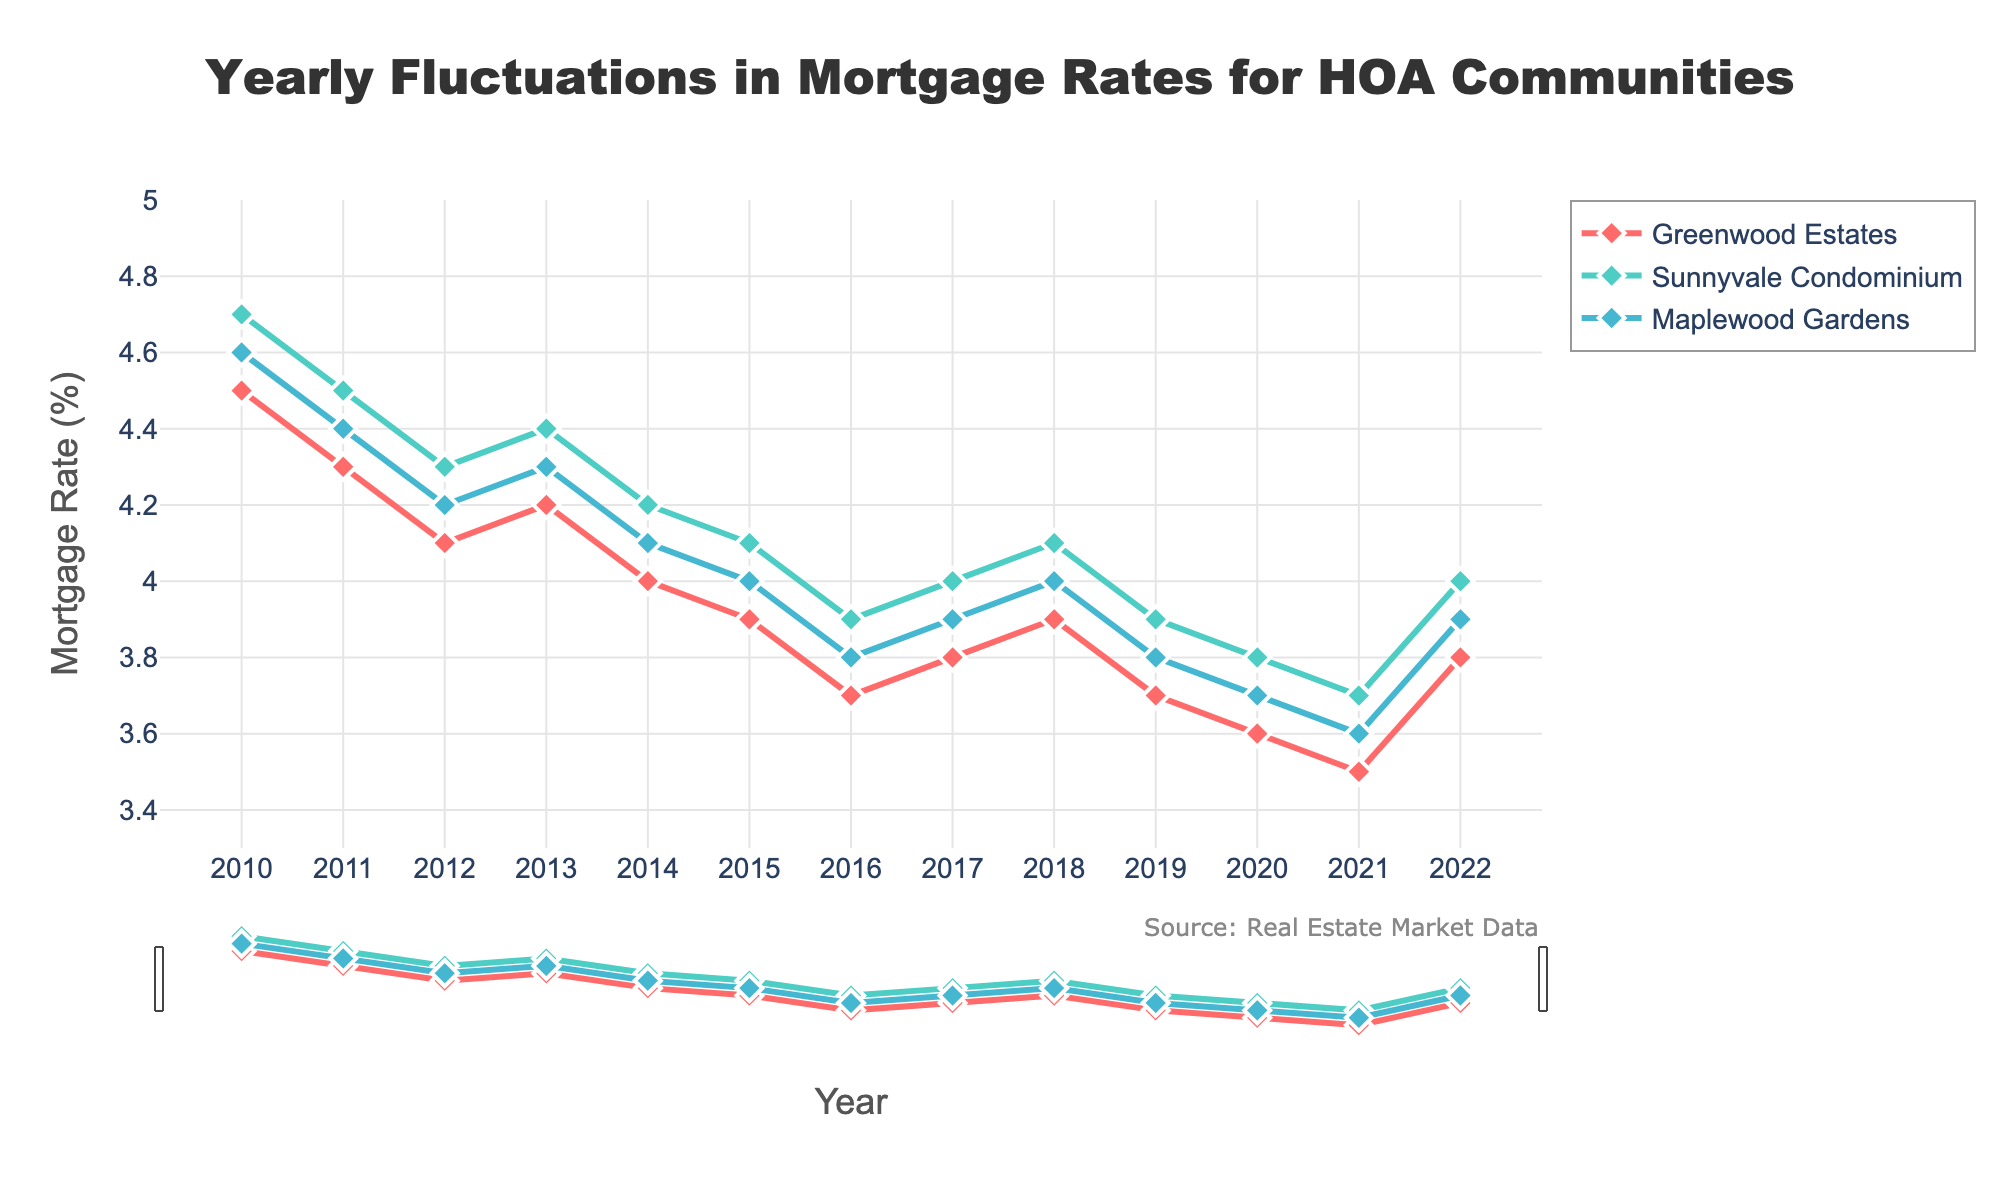What's the title of the plot? The title is displayed prominently at the top of the figure. It is "Yearly Fluctuations in Mortgage Rates for HOA Communities".
Answer: Yearly Fluctuations in Mortgage Rates for HOA Communities Which community has the lowest mortgage rate in 2016? Find the year 2016 on the x-axis, then see which community's line is at the lowest point on the y-axis. Greenwood Estates has the lowest rate of 3.7%.
Answer: Greenwood Estates In which year did all communities have the same mortgage rate? Compare the lines for all three communities year by year. In 2013, all communities had virtually the same mortgage rate of about 4.2-4.4%.
Answer: 2013 What's the trend of mortgage rates for Greenwood Estates from 2010 to 2022? Observe the line for Greenwood Estates from 2010 to 2022. The rate generally decreases until 2021, then slightly increases in 2022.
Answer: Decreasing, then slightly increasing in 2022 Which community exhibited the most stable mortgage rate fluctuations over the years? Look at the slopes of the lines for each community. Sunnyvale Condominium's line shows the least fluctuation.
Answer: Sunnyvale Condominium By how much did the mortgage rate for Maplewood Gardens decrease from 2010 to 2020? Subtract Maplewood Gardens' 2020 rate from its 2010 rate: 4.6 - 3.7 = 0.9%.
Answer: 0.9% Which year had the highest mortgage rate for Sunnyvale Condominium? Find the peak point on the line for Sunnyvale Condominium. The highest rate was in 2010, at 4.7%.
Answer: 2010 Which community had the highest mortgage rate in 2022? Look up the year 2022 and find the highest point among all communities' lines. Sunnyvale Condominium had the highest rate of 4.0%.
Answer: Sunnyvale Condominium What's the minimum mortgage rate for any community over the entire period? Identify the lowest point on the y-axis across all lines. The lowest rate was 3.5% for Greenwood Estates in 2021.
Answer: 3.5% From 2017 to 2019, how did the mortgage rates for Sunnyvale Condominium change? Track the line for Sunnyvale Condominium from 2017 to 2019. It decreased from 4.0% to 3.9%.
Answer: Decreased by 0.1% 